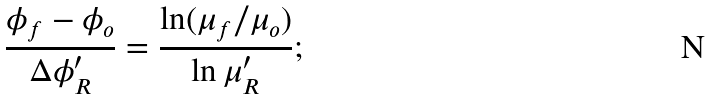Convert formula to latex. <formula><loc_0><loc_0><loc_500><loc_500>\frac { \phi _ { f } - \phi _ { o } } { \Delta \phi _ { R } ^ { \prime } } = \frac { \ln ( \mu _ { f } / \mu _ { o } ) } { \ln \mu _ { R } ^ { \prime } } ;</formula> 